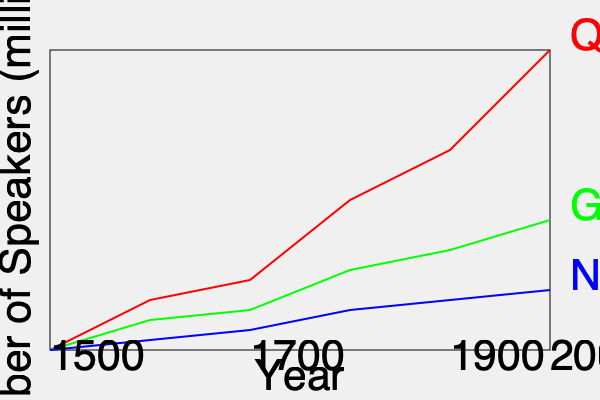Based on the color-coded map showing the spread of indigenous languages in Latin America from 1500 to 2000, which language experienced the most significant decline in speakers, and what factors might explain this trend? To answer this question, we need to analyze the graph and interpret the historical context:

1. Identify the languages: The graph shows three indigenous languages - Quechua (red), Guarani (green), and Nahuatl (blue).

2. Analyze the trends:
   - Quechua: Shows the steepest decline from 1500 to 2000.
   - Guarani: Experiences a moderate decline.
   - Nahuatl: Has the least decline among the three.

3. Quantify the decline:
   - Quechua: From about 300 million speakers in 1500 to around 50 million in 2000.
   - Guarani: From about 130 million in 1500 to about 80 million in 2000.
   - Nahuatl: From about 60 million in 1500 to about 40 million in 2000.

4. Identify the most significant decline: Quechua shows the most dramatic decrease in speakers.

5. Factors explaining the trend:
   a) Spanish colonization: The arrival of Spanish colonizers in the 16th century led to the imposition of Spanish as the dominant language.
   b) Cultural assimilation: Indigenous peoples were often forced to adopt Spanish culture and language.
   c) Population decline: Disease, warfare, and exploitation led to a significant decrease in indigenous populations.
   d) Economic factors: Spanish became the language of commerce and administration, incentivizing its adoption.
   e) Education policies: Many countries promoted Spanish-only education, discouraging the use of indigenous languages.
   f) Urbanization: Migration to cities often led to the loss of indigenous language use.

6. Quechua's specific case:
   - It was the language of the Inca Empire, which was conquered by the Spanish in the 16th century.
   - The Inca Empire's vast territory (modern-day Peru, Ecuador, Bolivia, and parts of Colombia, Chile, and Argentina) meant that Quechua had the most to lose in terms of speakers and geographic spread.
Answer: Quechua experienced the most significant decline due to Spanish colonization, cultural assimilation, population decline, economic factors, education policies, and urbanization. 